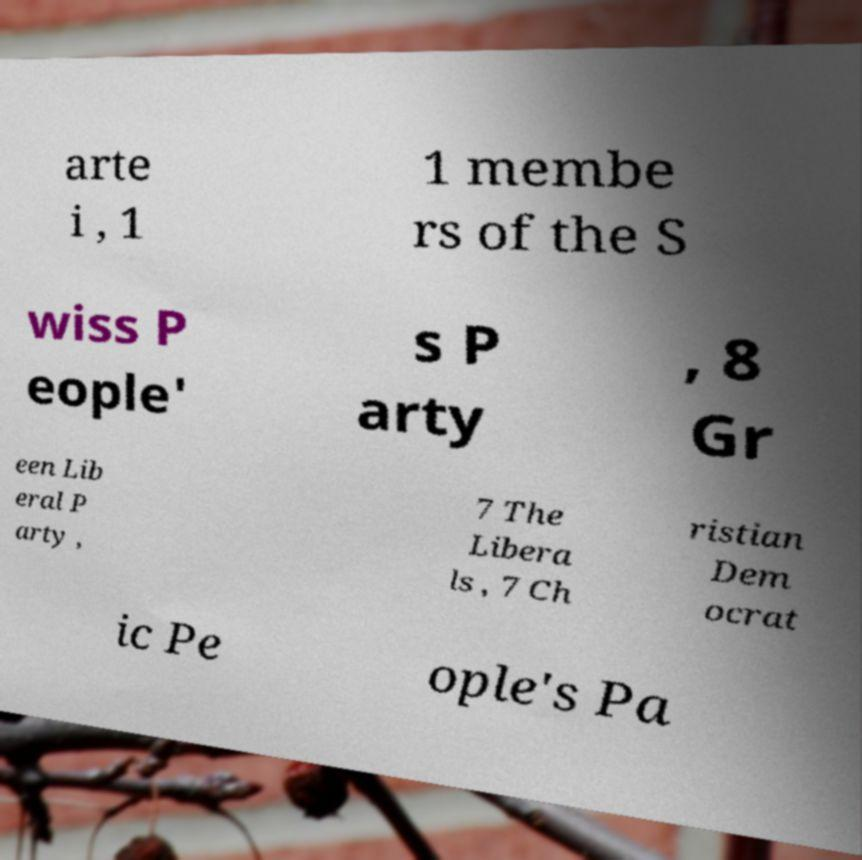Can you accurately transcribe the text from the provided image for me? arte i , 1 1 membe rs of the S wiss P eople' s P arty , 8 Gr een Lib eral P arty , 7 The Libera ls , 7 Ch ristian Dem ocrat ic Pe ople's Pa 